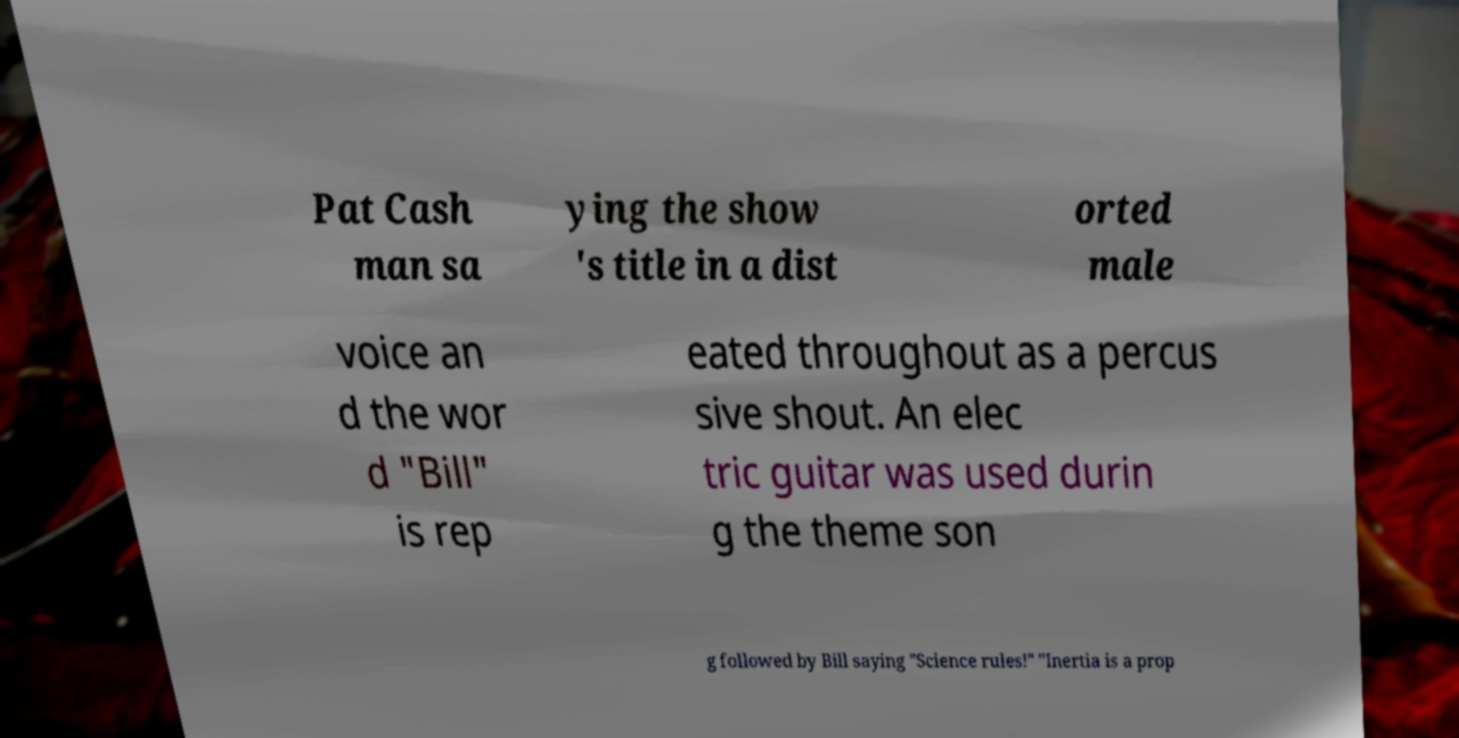What messages or text are displayed in this image? I need them in a readable, typed format. Pat Cash man sa ying the show 's title in a dist orted male voice an d the wor d "Bill" is rep eated throughout as a percus sive shout. An elec tric guitar was used durin g the theme son g followed by Bill saying "Science rules!" "Inertia is a prop 